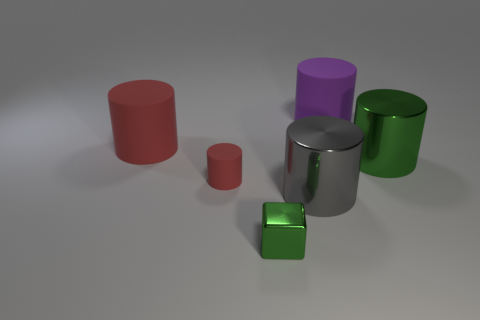Is the shape of the rubber thing on the left side of the tiny cylinder the same as  the purple rubber object?
Your answer should be very brief. Yes. Is the number of things that are in front of the gray metallic object less than the number of gray objects behind the large purple cylinder?
Offer a very short reply. No. What is the material of the big red thing?
Offer a terse response. Rubber. There is a metal cube; does it have the same color as the large shiny cylinder that is on the right side of the purple cylinder?
Keep it short and to the point. Yes. What number of big things are behind the small shiny thing?
Your response must be concise. 4. Is the number of large purple cylinders in front of the small metallic thing less than the number of red metallic cylinders?
Offer a very short reply. No. The small metal thing has what color?
Make the answer very short. Green. Is the color of the large matte thing in front of the large purple matte cylinder the same as the tiny cylinder?
Give a very brief answer. Yes. There is another large matte thing that is the same shape as the big red rubber object; what color is it?
Offer a very short reply. Purple. What number of tiny objects are blue rubber objects or cylinders?
Provide a short and direct response. 1. 